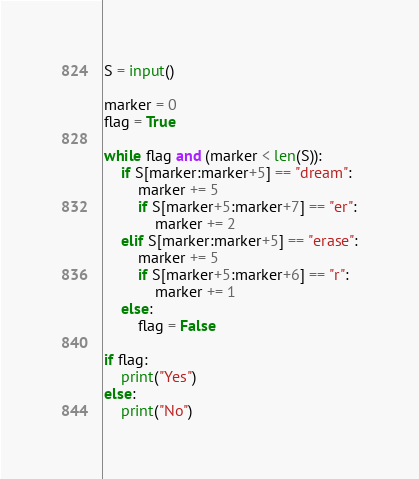<code> <loc_0><loc_0><loc_500><loc_500><_Python_>S = input()

marker = 0
flag = True

while flag and (marker < len(S)):
    if S[marker:marker+5] == "dream":
        marker += 5
        if S[marker+5:marker+7] == "er":
            marker += 2
    elif S[marker:marker+5] == "erase":
        marker += 5
        if S[marker+5:marker+6] == "r":
            marker += 1
    else:
        flag = False
        
if flag:
    print("Yes")
else:
    print("No")</code> 